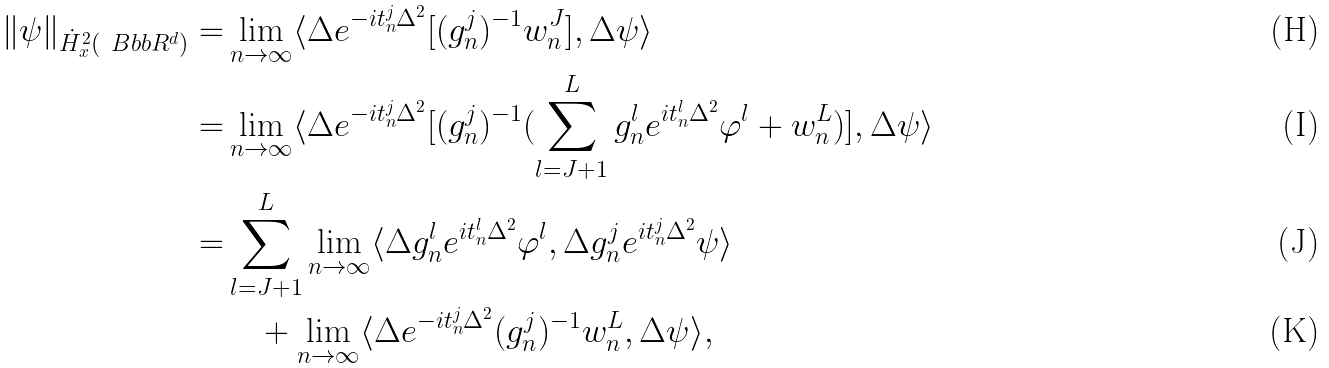Convert formula to latex. <formula><loc_0><loc_0><loc_500><loc_500>\| \psi \| _ { \dot { H } _ { x } ^ { 2 } ( \ B b b R ^ { d } ) } = & \lim _ { n \rightarrow \infty } \langle \Delta e ^ { - i t _ { n } ^ { j } \Delta ^ { 2 } } [ ( g _ { n } ^ { j } ) ^ { - 1 } w _ { n } ^ { J } ] , \Delta \psi \rangle \\ = & \lim _ { n \rightarrow \infty } \langle \Delta e ^ { - i t _ { n } ^ { j } \Delta ^ { 2 } } [ ( g _ { n } ^ { j } ) ^ { - 1 } ( \sum _ { l = J + 1 } ^ { L } g _ { n } ^ { l } e ^ { i t _ { n } ^ { l } \Delta ^ { 2 } } \varphi ^ { l } + w _ { n } ^ { L } ) ] , \Delta \psi \rangle \\ = & \sum _ { l = J + 1 } ^ { L } \lim _ { n \rightarrow \infty } \langle \Delta g _ { n } ^ { l } e ^ { i t _ { n } ^ { l } \Delta ^ { 2 } } \varphi ^ { l } , \Delta g _ { n } ^ { j } e ^ { i t _ { n } ^ { j } \Delta ^ { 2 } } \psi \rangle \\ & \quad + \lim _ { n \rightarrow \infty } \langle \Delta e ^ { - i t _ { n } ^ { j } \Delta ^ { 2 } } ( g _ { n } ^ { j } ) ^ { - 1 } w _ { n } ^ { L } , \Delta \psi \rangle ,</formula> 